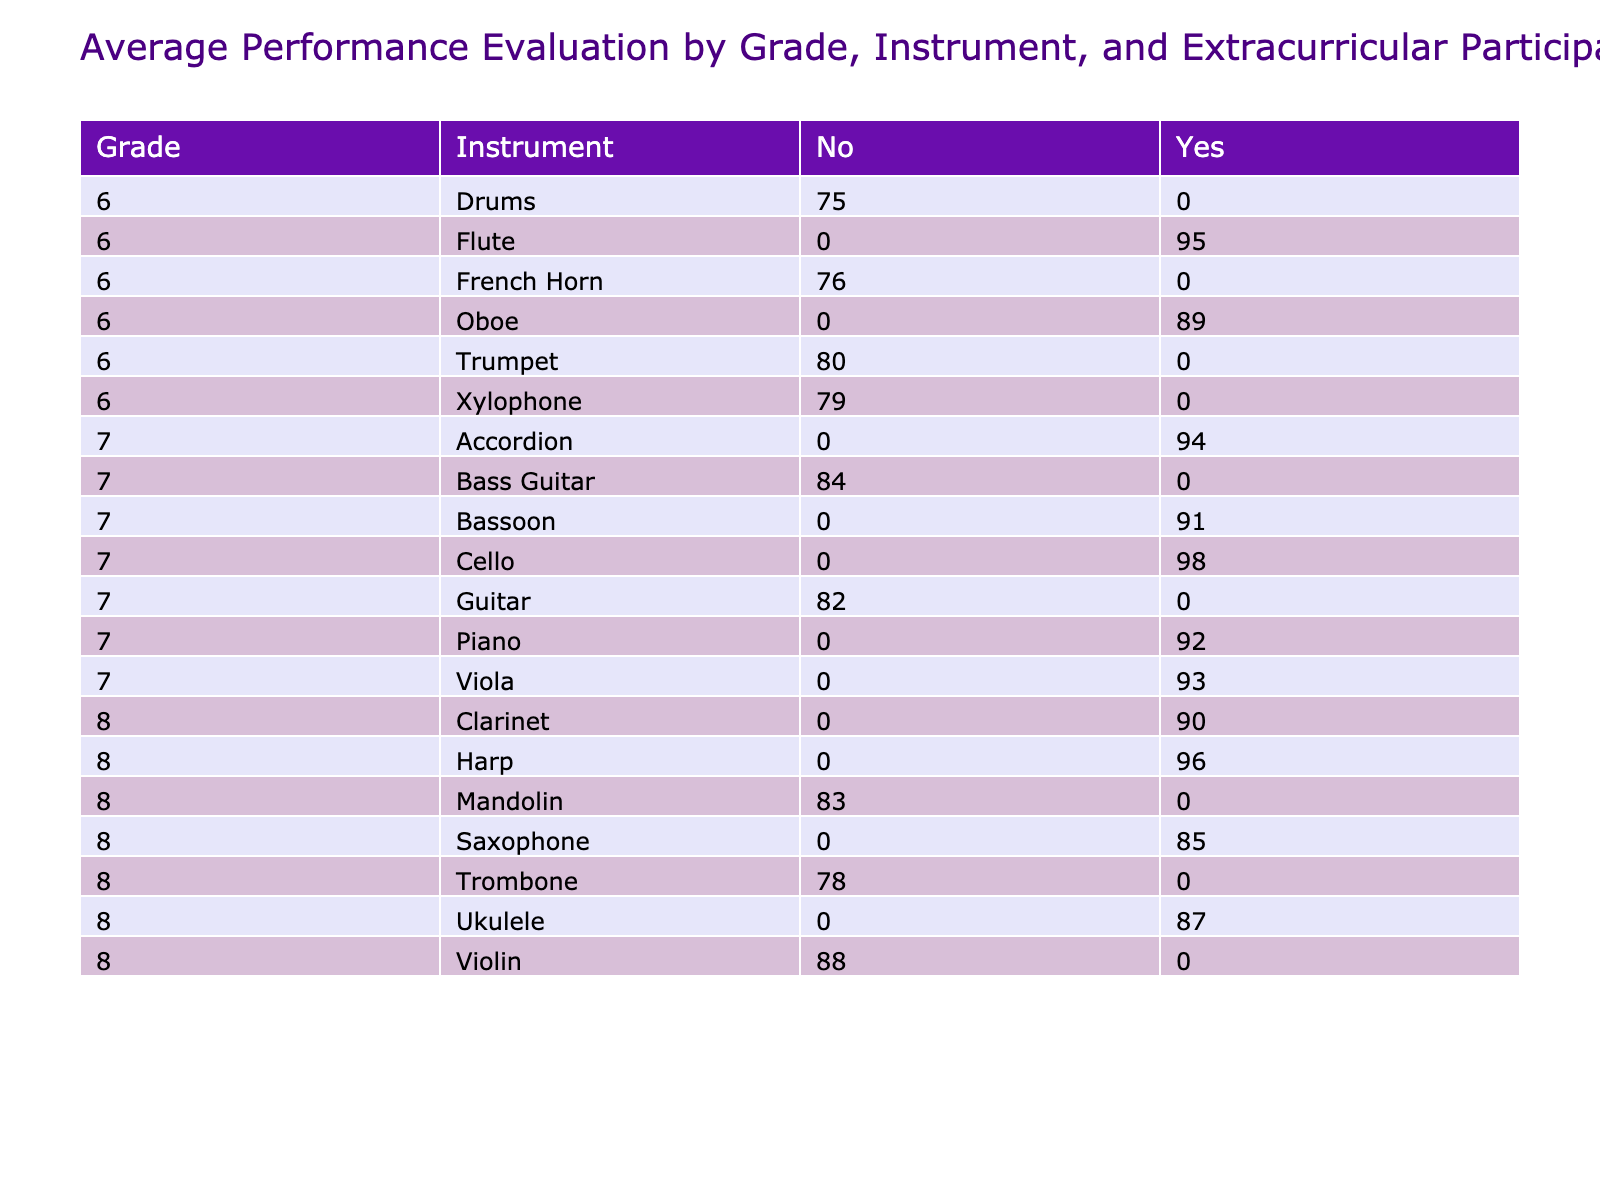What is the average performance evaluation score for students in grade 6 who participate in extracurricular music activities? To find this, we look at the pivot table for grade 6 under the 'Yes' column for extracurricular participation. There are two students: Sophia Rodriguez with a score of 95 and Liam Wilson with a score of 89. The average is (95 + 89) / 2 = 92.
Answer: 92 How many students in grade 7 play the violin and what is their average performance evaluation? Looking at the table, there is one student in grade 7 who plays the violin - Michael Chen, with a performance evaluation score of 88. Since there is only one student, the average is simply 88.
Answer: 88 What is the performance evaluation score difference between grade 8 students who participate in extracurricular activities and those who do not? From the table, we note two students in grade 8 who do not participate: Ryan White with 83 and Michael Chen with 88 who participates. The average for 'No' is (83 + 88) / 2 = 85.5 for participants and from the 'Yes' column, the score for Alexander Brown is 96. Thus, the difference is 96 - 85.5 = 10.5.
Answer: 10.5 Which instrument in grade 7 has the highest average performance evaluation for students who do not participate in extracurricular activities? In grade 7, examining the 'No' column, the only instruments recorded are Guitar (82) and Bass Guitar (84). The average for Guitar is lower than Bass Guitar's average, making Bass Guitar with a score of 84 the highest.
Answer: Bass Guitar Is there a grade 6 student who plays the drums and participates in extracurricular music activities? Looking through the table, Isabella Martinez is a grade 6 student who plays the drums but does not participate in extracurricular activities. Therefore, the answer is no, there is no grade 6 student playing drums who participates.
Answer: No 